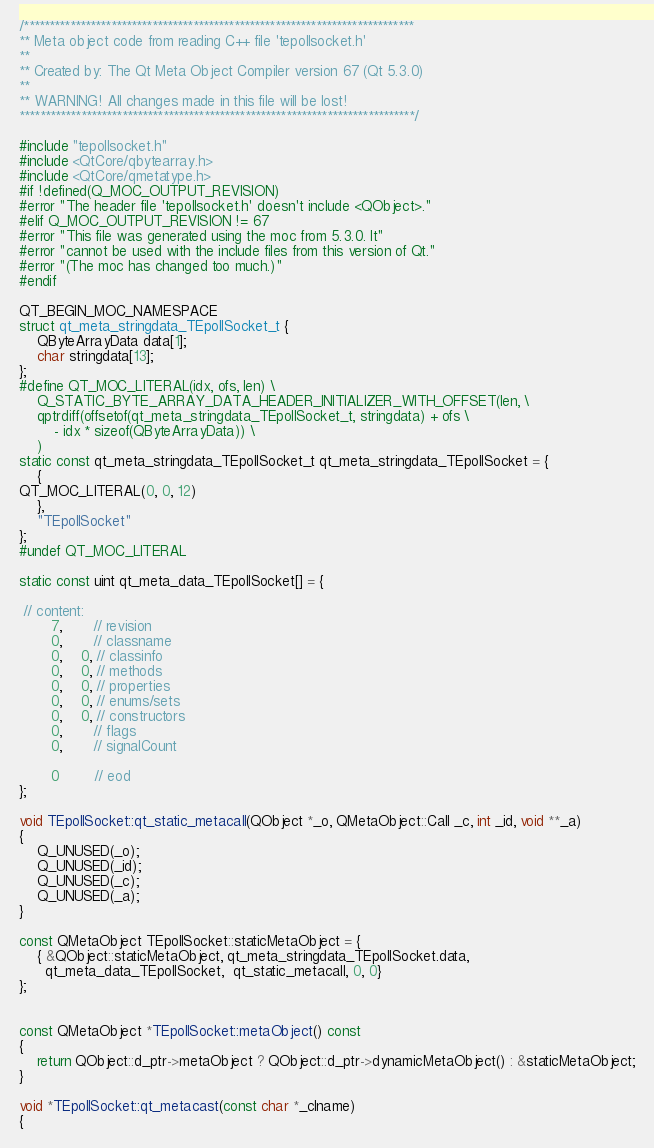<code> <loc_0><loc_0><loc_500><loc_500><_C++_>/****************************************************************************
** Meta object code from reading C++ file 'tepollsocket.h'
**
** Created by: The Qt Meta Object Compiler version 67 (Qt 5.3.0)
**
** WARNING! All changes made in this file will be lost!
*****************************************************************************/

#include "tepollsocket.h"
#include <QtCore/qbytearray.h>
#include <QtCore/qmetatype.h>
#if !defined(Q_MOC_OUTPUT_REVISION)
#error "The header file 'tepollsocket.h' doesn't include <QObject>."
#elif Q_MOC_OUTPUT_REVISION != 67
#error "This file was generated using the moc from 5.3.0. It"
#error "cannot be used with the include files from this version of Qt."
#error "(The moc has changed too much.)"
#endif

QT_BEGIN_MOC_NAMESPACE
struct qt_meta_stringdata_TEpollSocket_t {
    QByteArrayData data[1];
    char stringdata[13];
};
#define QT_MOC_LITERAL(idx, ofs, len) \
    Q_STATIC_BYTE_ARRAY_DATA_HEADER_INITIALIZER_WITH_OFFSET(len, \
    qptrdiff(offsetof(qt_meta_stringdata_TEpollSocket_t, stringdata) + ofs \
        - idx * sizeof(QByteArrayData)) \
    )
static const qt_meta_stringdata_TEpollSocket_t qt_meta_stringdata_TEpollSocket = {
    {
QT_MOC_LITERAL(0, 0, 12)
    },
    "TEpollSocket"
};
#undef QT_MOC_LITERAL

static const uint qt_meta_data_TEpollSocket[] = {

 // content:
       7,       // revision
       0,       // classname
       0,    0, // classinfo
       0,    0, // methods
       0,    0, // properties
       0,    0, // enums/sets
       0,    0, // constructors
       0,       // flags
       0,       // signalCount

       0        // eod
};

void TEpollSocket::qt_static_metacall(QObject *_o, QMetaObject::Call _c, int _id, void **_a)
{
    Q_UNUSED(_o);
    Q_UNUSED(_id);
    Q_UNUSED(_c);
    Q_UNUSED(_a);
}

const QMetaObject TEpollSocket::staticMetaObject = {
    { &QObject::staticMetaObject, qt_meta_stringdata_TEpollSocket.data,
      qt_meta_data_TEpollSocket,  qt_static_metacall, 0, 0}
};


const QMetaObject *TEpollSocket::metaObject() const
{
    return QObject::d_ptr->metaObject ? QObject::d_ptr->dynamicMetaObject() : &staticMetaObject;
}

void *TEpollSocket::qt_metacast(const char *_clname)
{</code> 